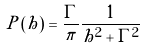Convert formula to latex. <formula><loc_0><loc_0><loc_500><loc_500>P \left ( h \right ) = \frac { \Gamma } { \pi } \frac { 1 } { h ^ { 2 } + \Gamma ^ { 2 } }</formula> 